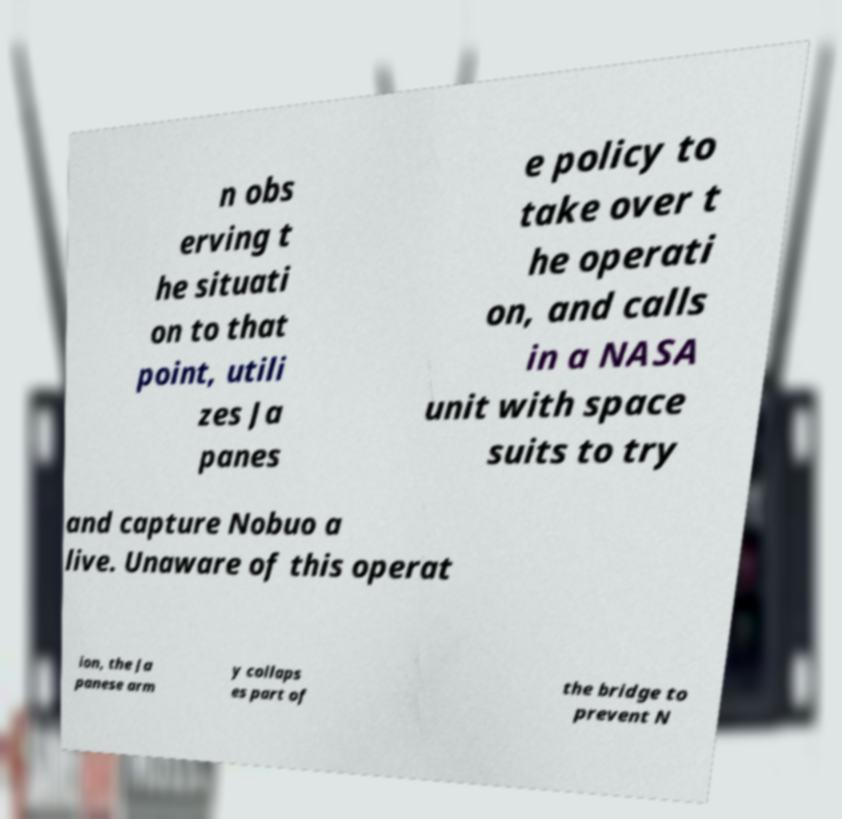Could you extract and type out the text from this image? n obs erving t he situati on to that point, utili zes Ja panes e policy to take over t he operati on, and calls in a NASA unit with space suits to try and capture Nobuo a live. Unaware of this operat ion, the Ja panese arm y collaps es part of the bridge to prevent N 